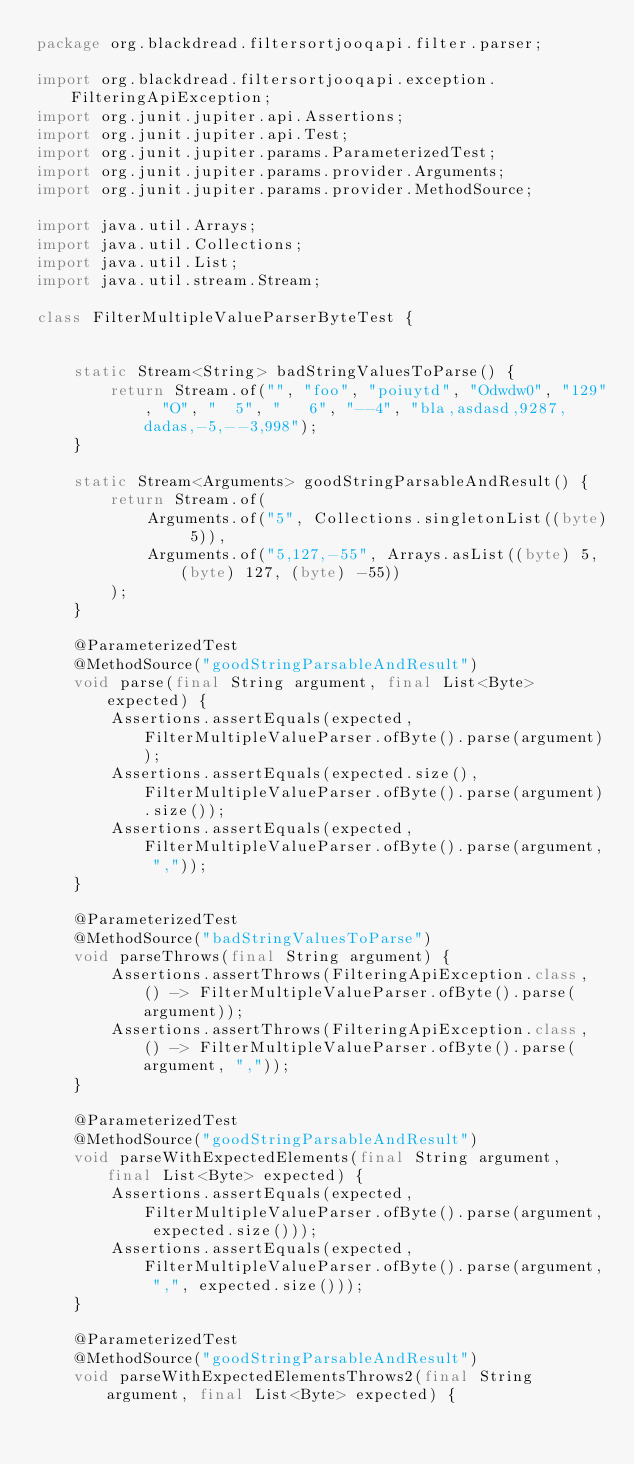Convert code to text. <code><loc_0><loc_0><loc_500><loc_500><_Java_>package org.blackdread.filtersortjooqapi.filter.parser;

import org.blackdread.filtersortjooqapi.exception.FilteringApiException;
import org.junit.jupiter.api.Assertions;
import org.junit.jupiter.api.Test;
import org.junit.jupiter.params.ParameterizedTest;
import org.junit.jupiter.params.provider.Arguments;
import org.junit.jupiter.params.provider.MethodSource;

import java.util.Arrays;
import java.util.Collections;
import java.util.List;
import java.util.stream.Stream;

class FilterMultipleValueParserByteTest {


    static Stream<String> badStringValuesToParse() {
        return Stream.of("", "foo", "poiuytd", "Odwdw0", "129", "O", "  5", "   6", "--4", "bla,asdasd,9287,dadas,-5,--3,998");
    }

    static Stream<Arguments> goodStringParsableAndResult() {
        return Stream.of(
            Arguments.of("5", Collections.singletonList((byte) 5)),
            Arguments.of("5,127,-55", Arrays.asList((byte) 5, (byte) 127, (byte) -55))
        );
    }

    @ParameterizedTest
    @MethodSource("goodStringParsableAndResult")
    void parse(final String argument, final List<Byte> expected) {
        Assertions.assertEquals(expected, FilterMultipleValueParser.ofByte().parse(argument));
        Assertions.assertEquals(expected.size(), FilterMultipleValueParser.ofByte().parse(argument).size());
        Assertions.assertEquals(expected, FilterMultipleValueParser.ofByte().parse(argument, ","));
    }

    @ParameterizedTest
    @MethodSource("badStringValuesToParse")
    void parseThrows(final String argument) {
        Assertions.assertThrows(FilteringApiException.class, () -> FilterMultipleValueParser.ofByte().parse(argument));
        Assertions.assertThrows(FilteringApiException.class, () -> FilterMultipleValueParser.ofByte().parse(argument, ","));
    }

    @ParameterizedTest
    @MethodSource("goodStringParsableAndResult")
    void parseWithExpectedElements(final String argument, final List<Byte> expected) {
        Assertions.assertEquals(expected, FilterMultipleValueParser.ofByte().parse(argument, expected.size()));
        Assertions.assertEquals(expected, FilterMultipleValueParser.ofByte().parse(argument, ",", expected.size()));
    }

    @ParameterizedTest
    @MethodSource("goodStringParsableAndResult")
    void parseWithExpectedElementsThrows2(final String argument, final List<Byte> expected) {</code> 